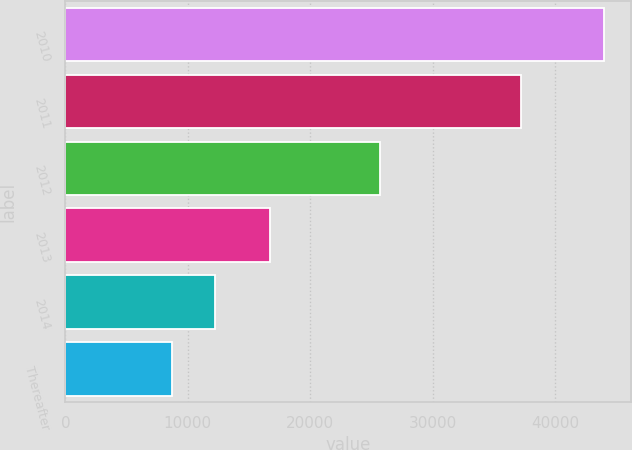Convert chart. <chart><loc_0><loc_0><loc_500><loc_500><bar_chart><fcel>2010<fcel>2011<fcel>2012<fcel>2013<fcel>2014<fcel>Thereafter<nl><fcel>44002<fcel>37214<fcel>25712<fcel>16686<fcel>12211.3<fcel>8679<nl></chart> 